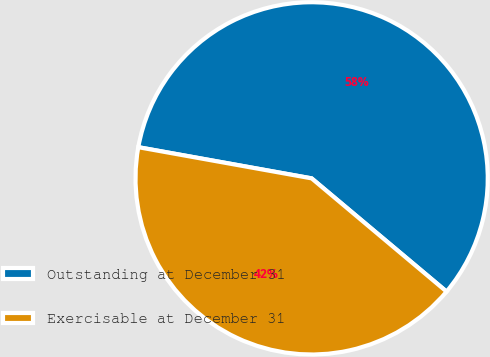Convert chart. <chart><loc_0><loc_0><loc_500><loc_500><pie_chart><fcel>Outstanding at December 31<fcel>Exercisable at December 31<nl><fcel>58.28%<fcel>41.72%<nl></chart> 